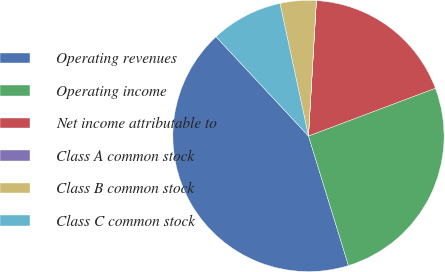Convert chart to OTSL. <chart><loc_0><loc_0><loc_500><loc_500><pie_chart><fcel>Operating revenues<fcel>Operating income<fcel>Net income attributable to<fcel>Class A common stock<fcel>Class B common stock<fcel>Class C common stock<nl><fcel>42.83%<fcel>25.96%<fcel>18.34%<fcel>0.01%<fcel>4.29%<fcel>8.57%<nl></chart> 